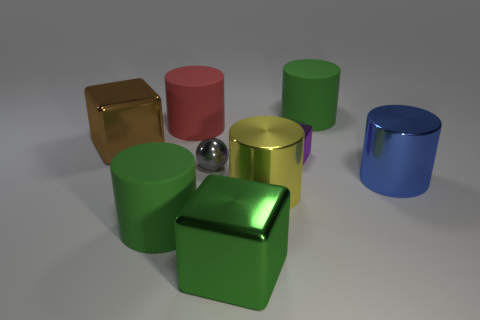Subtract 2 cylinders. How many cylinders are left? 3 Subtract all red cylinders. How many cylinders are left? 4 Subtract all big blue metallic cylinders. How many cylinders are left? 4 Subtract all cyan cylinders. Subtract all blue cubes. How many cylinders are left? 5 Subtract all cubes. How many objects are left? 6 Subtract 1 yellow cylinders. How many objects are left? 8 Subtract all purple metallic things. Subtract all large rubber objects. How many objects are left? 5 Add 6 small metallic things. How many small metallic things are left? 8 Add 4 tiny red objects. How many tiny red objects exist? 4 